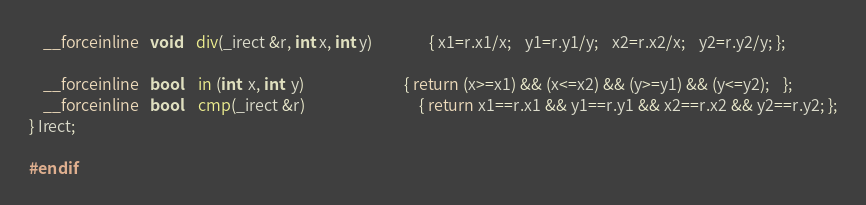Convert code to text. <code><loc_0><loc_0><loc_500><loc_500><_C_>	__forceinline   void	div(_irect &r, int x, int y)				{ x1=r.x1/x;	y1=r.y1/y;	x2=r.x2/x;	y2=r.y2/y; };

	__forceinline   bool	in (int  x, int  y)							{ return (x>=x1) && (x<=x2) && (y>=y1) && (y<=y2);	};
	__forceinline   bool	cmp(_irect &r)								{ return x1==r.x1 && y1==r.y1 && x2==r.x2 && y2==r.y2; };
} Irect;

#endif
</code> 